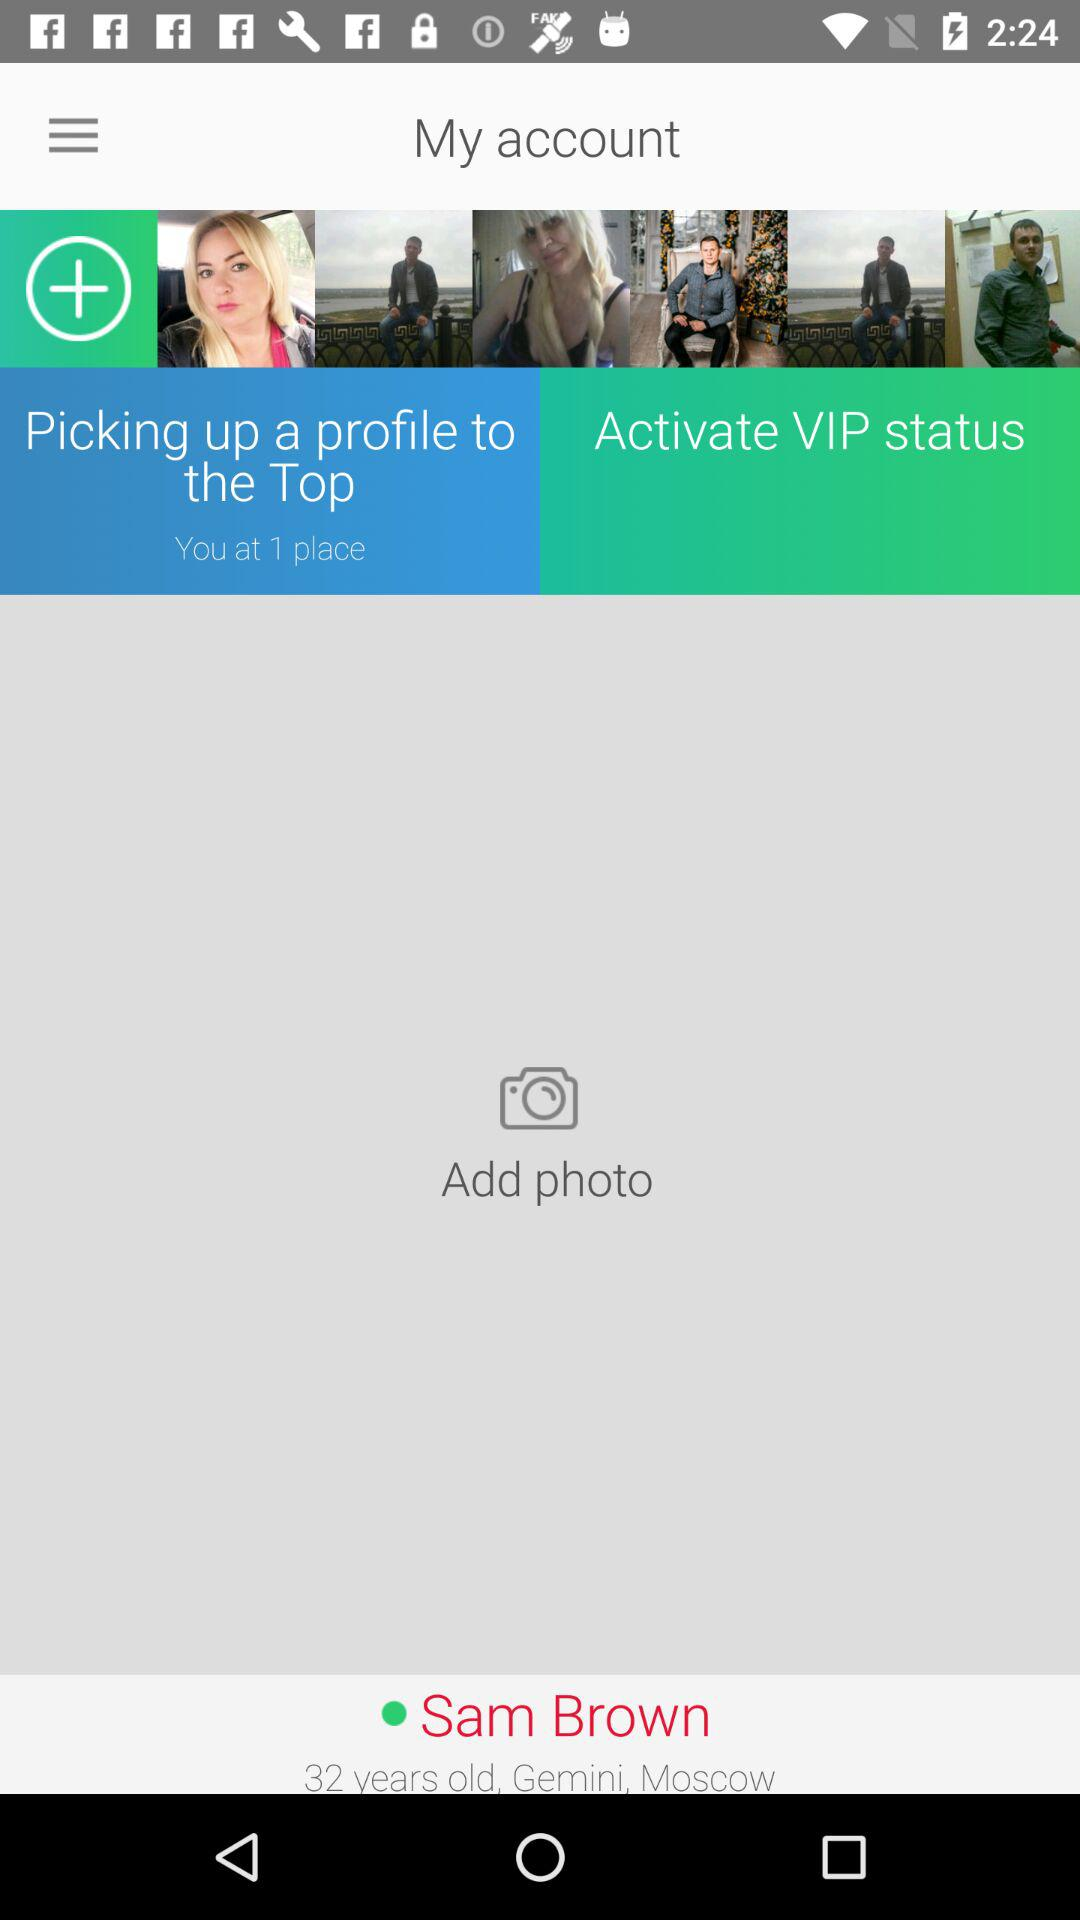Where does the user live? The user lives in Moscow. 